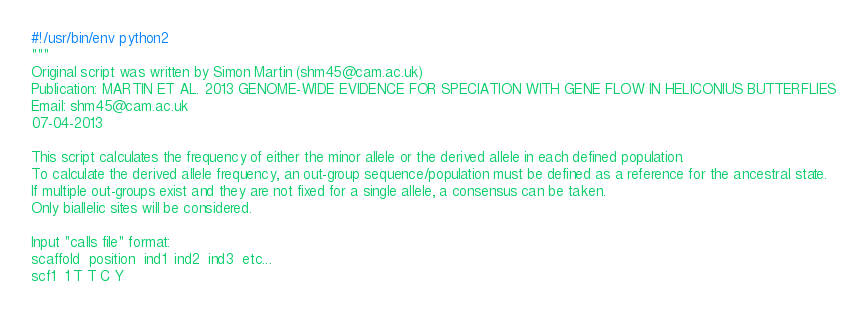Convert code to text. <code><loc_0><loc_0><loc_500><loc_500><_Python_>#!/usr/bin/env python2
"""
Original script was written by Simon Martin (shm45@cam.ac.uk)
Publication: MARTIN ET AL. 2013 GENOME-WIDE EVIDENCE FOR SPECIATION WITH GENE FLOW IN HELICONIUS BUTTERFLIES
Email: shm45@cam.ac.uk
07-04-2013

This script calculates the frequency of either the minor allele or the derived allele in each defined population.
To calculate the derived allele frequency, an out-group sequence/population must be defined as a reference for the ancestral state.
If multiple out-groups exist and they are not fixed for a single allele, a consensus can be taken.
Only biallelic sites will be considered.

Input "calls file" format:
scaffold  position  ind1  ind2  ind3  etc...
scf1  1 T T C Y
</code> 